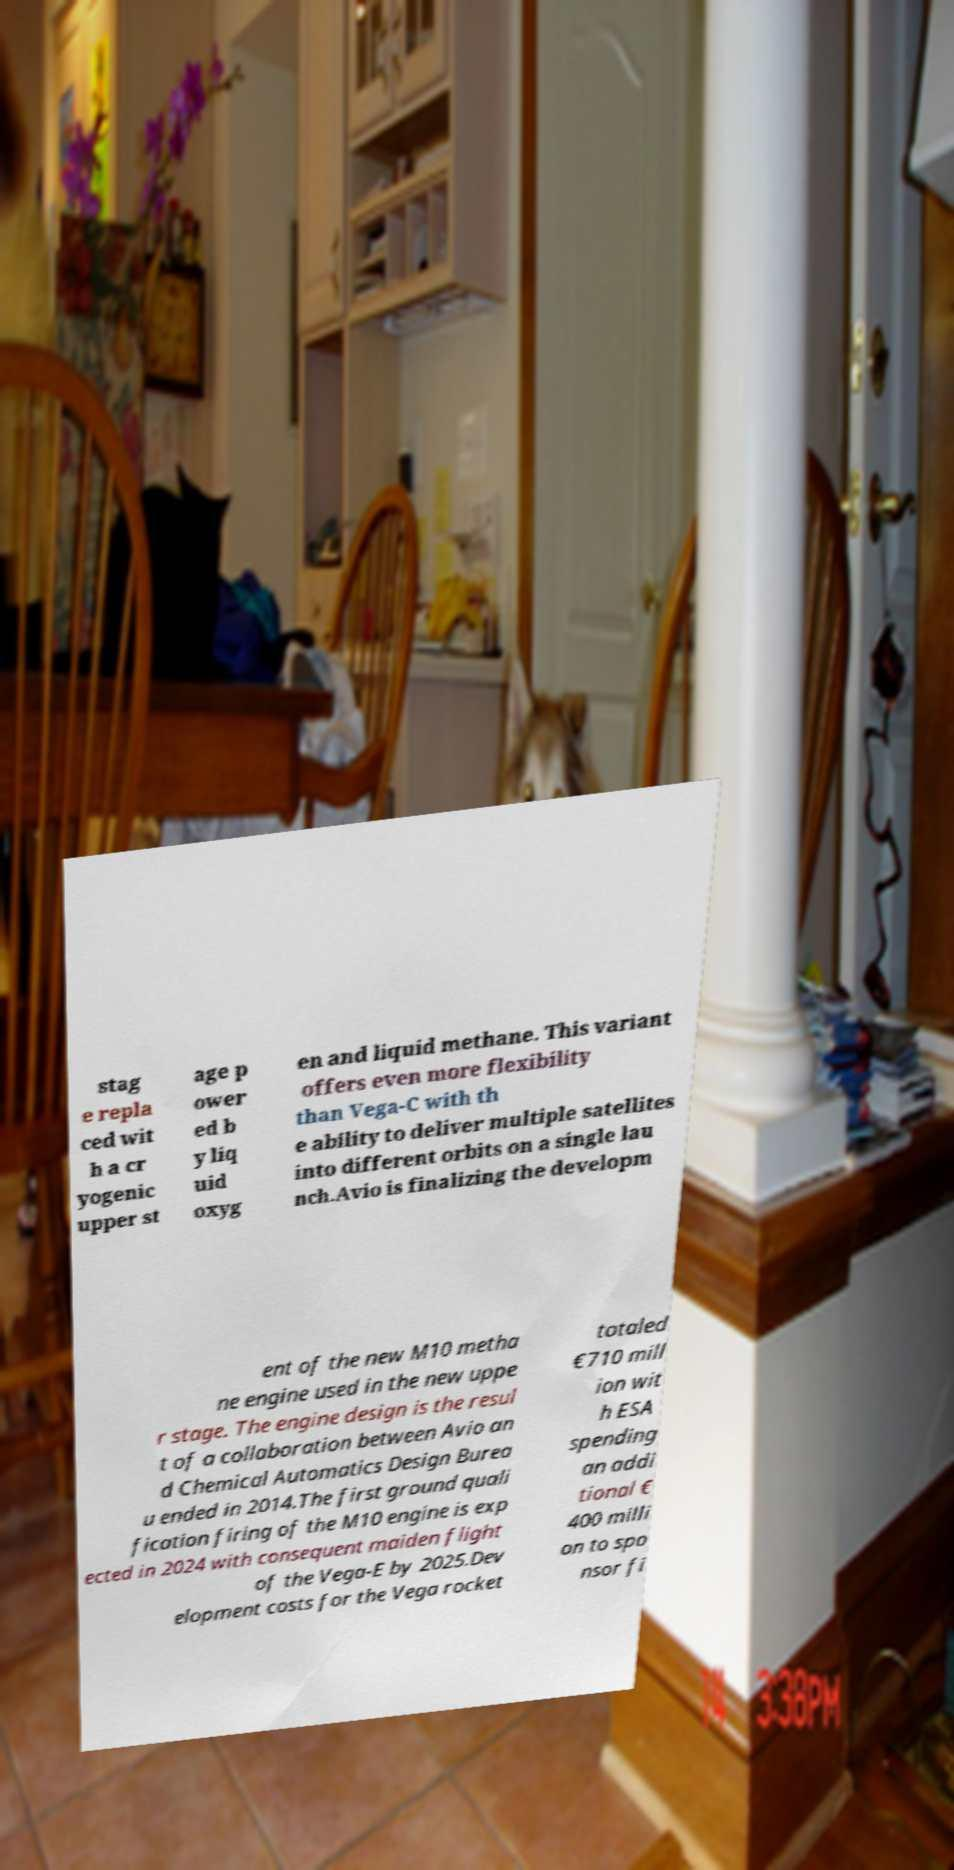Could you assist in decoding the text presented in this image and type it out clearly? stag e repla ced wit h a cr yogenic upper st age p ower ed b y liq uid oxyg en and liquid methane. This variant offers even more flexibility than Vega-C with th e ability to deliver multiple satellites into different orbits on a single lau nch.Avio is finalizing the developm ent of the new M10 metha ne engine used in the new uppe r stage. The engine design is the resul t of a collaboration between Avio an d Chemical Automatics Design Burea u ended in 2014.The first ground quali fication firing of the M10 engine is exp ected in 2024 with consequent maiden flight of the Vega-E by 2025.Dev elopment costs for the Vega rocket totaled €710 mill ion wit h ESA spending an addi tional € 400 milli on to spo nsor fi 